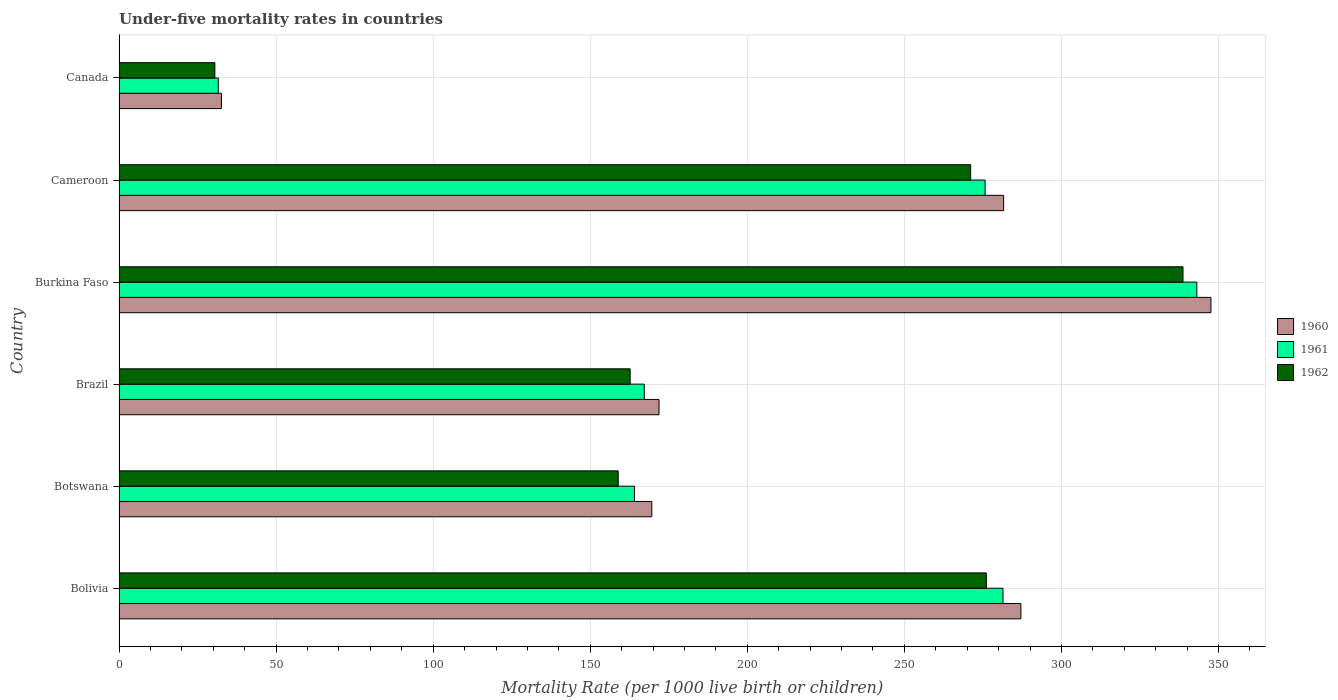Are the number of bars per tick equal to the number of legend labels?
Your response must be concise. Yes. How many bars are there on the 3rd tick from the top?
Keep it short and to the point. 3. How many bars are there on the 5th tick from the bottom?
Offer a terse response. 3. What is the label of the 5th group of bars from the top?
Give a very brief answer. Botswana. What is the under-five mortality rate in 1962 in Cameroon?
Offer a very short reply. 271.1. Across all countries, what is the maximum under-five mortality rate in 1962?
Offer a terse response. 338.7. Across all countries, what is the minimum under-five mortality rate in 1961?
Ensure brevity in your answer.  31.6. In which country was the under-five mortality rate in 1962 maximum?
Your response must be concise. Burkina Faso. In which country was the under-five mortality rate in 1962 minimum?
Ensure brevity in your answer.  Canada. What is the total under-five mortality rate in 1960 in the graph?
Keep it short and to the point. 1290.4. What is the difference between the under-five mortality rate in 1962 in Bolivia and that in Botswana?
Provide a short and direct response. 117.2. What is the difference between the under-five mortality rate in 1962 in Cameroon and the under-five mortality rate in 1961 in Brazil?
Keep it short and to the point. 103.9. What is the average under-five mortality rate in 1961 per country?
Ensure brevity in your answer.  210.52. What is the ratio of the under-five mortality rate in 1960 in Bolivia to that in Canada?
Provide a short and direct response. 8.81. Is the difference between the under-five mortality rate in 1960 in Bolivia and Canada greater than the difference between the under-five mortality rate in 1961 in Bolivia and Canada?
Your answer should be compact. Yes. What is the difference between the highest and the second highest under-five mortality rate in 1960?
Your answer should be compact. 60.5. What is the difference between the highest and the lowest under-five mortality rate in 1961?
Ensure brevity in your answer.  311.5. In how many countries, is the under-five mortality rate in 1961 greater than the average under-five mortality rate in 1961 taken over all countries?
Provide a succinct answer. 3. What does the 1st bar from the top in Cameroon represents?
Offer a very short reply. 1962. Is it the case that in every country, the sum of the under-five mortality rate in 1960 and under-five mortality rate in 1961 is greater than the under-five mortality rate in 1962?
Your response must be concise. Yes. Are all the bars in the graph horizontal?
Your answer should be very brief. Yes. How many countries are there in the graph?
Your answer should be very brief. 6. What is the difference between two consecutive major ticks on the X-axis?
Ensure brevity in your answer.  50. Are the values on the major ticks of X-axis written in scientific E-notation?
Your answer should be compact. No. Does the graph contain any zero values?
Offer a very short reply. No. Where does the legend appear in the graph?
Ensure brevity in your answer.  Center right. How are the legend labels stacked?
Your response must be concise. Vertical. What is the title of the graph?
Ensure brevity in your answer.  Under-five mortality rates in countries. What is the label or title of the X-axis?
Offer a terse response. Mortality Rate (per 1000 live birth or children). What is the Mortality Rate (per 1000 live birth or children) in 1960 in Bolivia?
Give a very brief answer. 287.1. What is the Mortality Rate (per 1000 live birth or children) of 1961 in Bolivia?
Your answer should be compact. 281.4. What is the Mortality Rate (per 1000 live birth or children) of 1962 in Bolivia?
Keep it short and to the point. 276.1. What is the Mortality Rate (per 1000 live birth or children) in 1960 in Botswana?
Your answer should be compact. 169.6. What is the Mortality Rate (per 1000 live birth or children) in 1961 in Botswana?
Give a very brief answer. 164.1. What is the Mortality Rate (per 1000 live birth or children) of 1962 in Botswana?
Keep it short and to the point. 158.9. What is the Mortality Rate (per 1000 live birth or children) in 1960 in Brazil?
Offer a very short reply. 171.9. What is the Mortality Rate (per 1000 live birth or children) of 1961 in Brazil?
Your answer should be very brief. 167.2. What is the Mortality Rate (per 1000 live birth or children) in 1962 in Brazil?
Your response must be concise. 162.7. What is the Mortality Rate (per 1000 live birth or children) in 1960 in Burkina Faso?
Provide a short and direct response. 347.6. What is the Mortality Rate (per 1000 live birth or children) in 1961 in Burkina Faso?
Offer a very short reply. 343.1. What is the Mortality Rate (per 1000 live birth or children) of 1962 in Burkina Faso?
Make the answer very short. 338.7. What is the Mortality Rate (per 1000 live birth or children) of 1960 in Cameroon?
Your answer should be very brief. 281.6. What is the Mortality Rate (per 1000 live birth or children) in 1961 in Cameroon?
Ensure brevity in your answer.  275.7. What is the Mortality Rate (per 1000 live birth or children) of 1962 in Cameroon?
Give a very brief answer. 271.1. What is the Mortality Rate (per 1000 live birth or children) of 1960 in Canada?
Your response must be concise. 32.6. What is the Mortality Rate (per 1000 live birth or children) in 1961 in Canada?
Provide a short and direct response. 31.6. What is the Mortality Rate (per 1000 live birth or children) in 1962 in Canada?
Make the answer very short. 30.5. Across all countries, what is the maximum Mortality Rate (per 1000 live birth or children) of 1960?
Provide a short and direct response. 347.6. Across all countries, what is the maximum Mortality Rate (per 1000 live birth or children) in 1961?
Ensure brevity in your answer.  343.1. Across all countries, what is the maximum Mortality Rate (per 1000 live birth or children) in 1962?
Your answer should be compact. 338.7. Across all countries, what is the minimum Mortality Rate (per 1000 live birth or children) in 1960?
Offer a very short reply. 32.6. Across all countries, what is the minimum Mortality Rate (per 1000 live birth or children) in 1961?
Give a very brief answer. 31.6. Across all countries, what is the minimum Mortality Rate (per 1000 live birth or children) in 1962?
Ensure brevity in your answer.  30.5. What is the total Mortality Rate (per 1000 live birth or children) of 1960 in the graph?
Offer a terse response. 1290.4. What is the total Mortality Rate (per 1000 live birth or children) of 1961 in the graph?
Your answer should be very brief. 1263.1. What is the total Mortality Rate (per 1000 live birth or children) of 1962 in the graph?
Ensure brevity in your answer.  1238. What is the difference between the Mortality Rate (per 1000 live birth or children) in 1960 in Bolivia and that in Botswana?
Give a very brief answer. 117.5. What is the difference between the Mortality Rate (per 1000 live birth or children) of 1961 in Bolivia and that in Botswana?
Your answer should be very brief. 117.3. What is the difference between the Mortality Rate (per 1000 live birth or children) of 1962 in Bolivia and that in Botswana?
Provide a succinct answer. 117.2. What is the difference between the Mortality Rate (per 1000 live birth or children) in 1960 in Bolivia and that in Brazil?
Keep it short and to the point. 115.2. What is the difference between the Mortality Rate (per 1000 live birth or children) of 1961 in Bolivia and that in Brazil?
Provide a succinct answer. 114.2. What is the difference between the Mortality Rate (per 1000 live birth or children) in 1962 in Bolivia and that in Brazil?
Your answer should be very brief. 113.4. What is the difference between the Mortality Rate (per 1000 live birth or children) in 1960 in Bolivia and that in Burkina Faso?
Offer a very short reply. -60.5. What is the difference between the Mortality Rate (per 1000 live birth or children) of 1961 in Bolivia and that in Burkina Faso?
Give a very brief answer. -61.7. What is the difference between the Mortality Rate (per 1000 live birth or children) of 1962 in Bolivia and that in Burkina Faso?
Offer a very short reply. -62.6. What is the difference between the Mortality Rate (per 1000 live birth or children) of 1960 in Bolivia and that in Cameroon?
Provide a short and direct response. 5.5. What is the difference between the Mortality Rate (per 1000 live birth or children) in 1961 in Bolivia and that in Cameroon?
Offer a terse response. 5.7. What is the difference between the Mortality Rate (per 1000 live birth or children) in 1960 in Bolivia and that in Canada?
Your answer should be compact. 254.5. What is the difference between the Mortality Rate (per 1000 live birth or children) in 1961 in Bolivia and that in Canada?
Your answer should be compact. 249.8. What is the difference between the Mortality Rate (per 1000 live birth or children) of 1962 in Bolivia and that in Canada?
Make the answer very short. 245.6. What is the difference between the Mortality Rate (per 1000 live birth or children) of 1961 in Botswana and that in Brazil?
Provide a succinct answer. -3.1. What is the difference between the Mortality Rate (per 1000 live birth or children) of 1962 in Botswana and that in Brazil?
Give a very brief answer. -3.8. What is the difference between the Mortality Rate (per 1000 live birth or children) in 1960 in Botswana and that in Burkina Faso?
Keep it short and to the point. -178. What is the difference between the Mortality Rate (per 1000 live birth or children) in 1961 in Botswana and that in Burkina Faso?
Make the answer very short. -179. What is the difference between the Mortality Rate (per 1000 live birth or children) in 1962 in Botswana and that in Burkina Faso?
Offer a terse response. -179.8. What is the difference between the Mortality Rate (per 1000 live birth or children) of 1960 in Botswana and that in Cameroon?
Your response must be concise. -112. What is the difference between the Mortality Rate (per 1000 live birth or children) in 1961 in Botswana and that in Cameroon?
Make the answer very short. -111.6. What is the difference between the Mortality Rate (per 1000 live birth or children) in 1962 in Botswana and that in Cameroon?
Offer a very short reply. -112.2. What is the difference between the Mortality Rate (per 1000 live birth or children) in 1960 in Botswana and that in Canada?
Your answer should be very brief. 137. What is the difference between the Mortality Rate (per 1000 live birth or children) in 1961 in Botswana and that in Canada?
Ensure brevity in your answer.  132.5. What is the difference between the Mortality Rate (per 1000 live birth or children) in 1962 in Botswana and that in Canada?
Offer a very short reply. 128.4. What is the difference between the Mortality Rate (per 1000 live birth or children) of 1960 in Brazil and that in Burkina Faso?
Your response must be concise. -175.7. What is the difference between the Mortality Rate (per 1000 live birth or children) of 1961 in Brazil and that in Burkina Faso?
Offer a terse response. -175.9. What is the difference between the Mortality Rate (per 1000 live birth or children) in 1962 in Brazil and that in Burkina Faso?
Give a very brief answer. -176. What is the difference between the Mortality Rate (per 1000 live birth or children) of 1960 in Brazil and that in Cameroon?
Your answer should be very brief. -109.7. What is the difference between the Mortality Rate (per 1000 live birth or children) in 1961 in Brazil and that in Cameroon?
Your response must be concise. -108.5. What is the difference between the Mortality Rate (per 1000 live birth or children) in 1962 in Brazil and that in Cameroon?
Provide a succinct answer. -108.4. What is the difference between the Mortality Rate (per 1000 live birth or children) of 1960 in Brazil and that in Canada?
Your answer should be very brief. 139.3. What is the difference between the Mortality Rate (per 1000 live birth or children) of 1961 in Brazil and that in Canada?
Your response must be concise. 135.6. What is the difference between the Mortality Rate (per 1000 live birth or children) in 1962 in Brazil and that in Canada?
Your answer should be compact. 132.2. What is the difference between the Mortality Rate (per 1000 live birth or children) in 1960 in Burkina Faso and that in Cameroon?
Provide a succinct answer. 66. What is the difference between the Mortality Rate (per 1000 live birth or children) of 1961 in Burkina Faso and that in Cameroon?
Offer a very short reply. 67.4. What is the difference between the Mortality Rate (per 1000 live birth or children) of 1962 in Burkina Faso and that in Cameroon?
Your answer should be compact. 67.6. What is the difference between the Mortality Rate (per 1000 live birth or children) in 1960 in Burkina Faso and that in Canada?
Your answer should be compact. 315. What is the difference between the Mortality Rate (per 1000 live birth or children) of 1961 in Burkina Faso and that in Canada?
Give a very brief answer. 311.5. What is the difference between the Mortality Rate (per 1000 live birth or children) of 1962 in Burkina Faso and that in Canada?
Provide a succinct answer. 308.2. What is the difference between the Mortality Rate (per 1000 live birth or children) in 1960 in Cameroon and that in Canada?
Offer a terse response. 249. What is the difference between the Mortality Rate (per 1000 live birth or children) of 1961 in Cameroon and that in Canada?
Make the answer very short. 244.1. What is the difference between the Mortality Rate (per 1000 live birth or children) in 1962 in Cameroon and that in Canada?
Ensure brevity in your answer.  240.6. What is the difference between the Mortality Rate (per 1000 live birth or children) in 1960 in Bolivia and the Mortality Rate (per 1000 live birth or children) in 1961 in Botswana?
Keep it short and to the point. 123. What is the difference between the Mortality Rate (per 1000 live birth or children) in 1960 in Bolivia and the Mortality Rate (per 1000 live birth or children) in 1962 in Botswana?
Your answer should be compact. 128.2. What is the difference between the Mortality Rate (per 1000 live birth or children) in 1961 in Bolivia and the Mortality Rate (per 1000 live birth or children) in 1962 in Botswana?
Provide a succinct answer. 122.5. What is the difference between the Mortality Rate (per 1000 live birth or children) of 1960 in Bolivia and the Mortality Rate (per 1000 live birth or children) of 1961 in Brazil?
Offer a terse response. 119.9. What is the difference between the Mortality Rate (per 1000 live birth or children) in 1960 in Bolivia and the Mortality Rate (per 1000 live birth or children) in 1962 in Brazil?
Ensure brevity in your answer.  124.4. What is the difference between the Mortality Rate (per 1000 live birth or children) in 1961 in Bolivia and the Mortality Rate (per 1000 live birth or children) in 1962 in Brazil?
Offer a terse response. 118.7. What is the difference between the Mortality Rate (per 1000 live birth or children) of 1960 in Bolivia and the Mortality Rate (per 1000 live birth or children) of 1961 in Burkina Faso?
Provide a short and direct response. -56. What is the difference between the Mortality Rate (per 1000 live birth or children) of 1960 in Bolivia and the Mortality Rate (per 1000 live birth or children) of 1962 in Burkina Faso?
Provide a succinct answer. -51.6. What is the difference between the Mortality Rate (per 1000 live birth or children) in 1961 in Bolivia and the Mortality Rate (per 1000 live birth or children) in 1962 in Burkina Faso?
Ensure brevity in your answer.  -57.3. What is the difference between the Mortality Rate (per 1000 live birth or children) in 1960 in Bolivia and the Mortality Rate (per 1000 live birth or children) in 1961 in Cameroon?
Your answer should be very brief. 11.4. What is the difference between the Mortality Rate (per 1000 live birth or children) of 1960 in Bolivia and the Mortality Rate (per 1000 live birth or children) of 1962 in Cameroon?
Give a very brief answer. 16. What is the difference between the Mortality Rate (per 1000 live birth or children) in 1961 in Bolivia and the Mortality Rate (per 1000 live birth or children) in 1962 in Cameroon?
Make the answer very short. 10.3. What is the difference between the Mortality Rate (per 1000 live birth or children) of 1960 in Bolivia and the Mortality Rate (per 1000 live birth or children) of 1961 in Canada?
Offer a very short reply. 255.5. What is the difference between the Mortality Rate (per 1000 live birth or children) of 1960 in Bolivia and the Mortality Rate (per 1000 live birth or children) of 1962 in Canada?
Keep it short and to the point. 256.6. What is the difference between the Mortality Rate (per 1000 live birth or children) in 1961 in Bolivia and the Mortality Rate (per 1000 live birth or children) in 1962 in Canada?
Offer a terse response. 250.9. What is the difference between the Mortality Rate (per 1000 live birth or children) of 1960 in Botswana and the Mortality Rate (per 1000 live birth or children) of 1961 in Brazil?
Offer a very short reply. 2.4. What is the difference between the Mortality Rate (per 1000 live birth or children) in 1961 in Botswana and the Mortality Rate (per 1000 live birth or children) in 1962 in Brazil?
Provide a short and direct response. 1.4. What is the difference between the Mortality Rate (per 1000 live birth or children) of 1960 in Botswana and the Mortality Rate (per 1000 live birth or children) of 1961 in Burkina Faso?
Ensure brevity in your answer.  -173.5. What is the difference between the Mortality Rate (per 1000 live birth or children) in 1960 in Botswana and the Mortality Rate (per 1000 live birth or children) in 1962 in Burkina Faso?
Give a very brief answer. -169.1. What is the difference between the Mortality Rate (per 1000 live birth or children) of 1961 in Botswana and the Mortality Rate (per 1000 live birth or children) of 1962 in Burkina Faso?
Make the answer very short. -174.6. What is the difference between the Mortality Rate (per 1000 live birth or children) of 1960 in Botswana and the Mortality Rate (per 1000 live birth or children) of 1961 in Cameroon?
Provide a short and direct response. -106.1. What is the difference between the Mortality Rate (per 1000 live birth or children) of 1960 in Botswana and the Mortality Rate (per 1000 live birth or children) of 1962 in Cameroon?
Provide a short and direct response. -101.5. What is the difference between the Mortality Rate (per 1000 live birth or children) of 1961 in Botswana and the Mortality Rate (per 1000 live birth or children) of 1962 in Cameroon?
Provide a short and direct response. -107. What is the difference between the Mortality Rate (per 1000 live birth or children) in 1960 in Botswana and the Mortality Rate (per 1000 live birth or children) in 1961 in Canada?
Offer a very short reply. 138. What is the difference between the Mortality Rate (per 1000 live birth or children) of 1960 in Botswana and the Mortality Rate (per 1000 live birth or children) of 1962 in Canada?
Offer a terse response. 139.1. What is the difference between the Mortality Rate (per 1000 live birth or children) of 1961 in Botswana and the Mortality Rate (per 1000 live birth or children) of 1962 in Canada?
Provide a succinct answer. 133.6. What is the difference between the Mortality Rate (per 1000 live birth or children) in 1960 in Brazil and the Mortality Rate (per 1000 live birth or children) in 1961 in Burkina Faso?
Keep it short and to the point. -171.2. What is the difference between the Mortality Rate (per 1000 live birth or children) of 1960 in Brazil and the Mortality Rate (per 1000 live birth or children) of 1962 in Burkina Faso?
Your answer should be compact. -166.8. What is the difference between the Mortality Rate (per 1000 live birth or children) of 1961 in Brazil and the Mortality Rate (per 1000 live birth or children) of 1962 in Burkina Faso?
Make the answer very short. -171.5. What is the difference between the Mortality Rate (per 1000 live birth or children) of 1960 in Brazil and the Mortality Rate (per 1000 live birth or children) of 1961 in Cameroon?
Give a very brief answer. -103.8. What is the difference between the Mortality Rate (per 1000 live birth or children) of 1960 in Brazil and the Mortality Rate (per 1000 live birth or children) of 1962 in Cameroon?
Provide a short and direct response. -99.2. What is the difference between the Mortality Rate (per 1000 live birth or children) in 1961 in Brazil and the Mortality Rate (per 1000 live birth or children) in 1962 in Cameroon?
Your response must be concise. -103.9. What is the difference between the Mortality Rate (per 1000 live birth or children) in 1960 in Brazil and the Mortality Rate (per 1000 live birth or children) in 1961 in Canada?
Your response must be concise. 140.3. What is the difference between the Mortality Rate (per 1000 live birth or children) in 1960 in Brazil and the Mortality Rate (per 1000 live birth or children) in 1962 in Canada?
Ensure brevity in your answer.  141.4. What is the difference between the Mortality Rate (per 1000 live birth or children) in 1961 in Brazil and the Mortality Rate (per 1000 live birth or children) in 1962 in Canada?
Keep it short and to the point. 136.7. What is the difference between the Mortality Rate (per 1000 live birth or children) in 1960 in Burkina Faso and the Mortality Rate (per 1000 live birth or children) in 1961 in Cameroon?
Offer a very short reply. 71.9. What is the difference between the Mortality Rate (per 1000 live birth or children) in 1960 in Burkina Faso and the Mortality Rate (per 1000 live birth or children) in 1962 in Cameroon?
Keep it short and to the point. 76.5. What is the difference between the Mortality Rate (per 1000 live birth or children) of 1961 in Burkina Faso and the Mortality Rate (per 1000 live birth or children) of 1962 in Cameroon?
Ensure brevity in your answer.  72. What is the difference between the Mortality Rate (per 1000 live birth or children) in 1960 in Burkina Faso and the Mortality Rate (per 1000 live birth or children) in 1961 in Canada?
Your answer should be compact. 316. What is the difference between the Mortality Rate (per 1000 live birth or children) of 1960 in Burkina Faso and the Mortality Rate (per 1000 live birth or children) of 1962 in Canada?
Your answer should be compact. 317.1. What is the difference between the Mortality Rate (per 1000 live birth or children) of 1961 in Burkina Faso and the Mortality Rate (per 1000 live birth or children) of 1962 in Canada?
Keep it short and to the point. 312.6. What is the difference between the Mortality Rate (per 1000 live birth or children) of 1960 in Cameroon and the Mortality Rate (per 1000 live birth or children) of 1961 in Canada?
Offer a terse response. 250. What is the difference between the Mortality Rate (per 1000 live birth or children) of 1960 in Cameroon and the Mortality Rate (per 1000 live birth or children) of 1962 in Canada?
Provide a short and direct response. 251.1. What is the difference between the Mortality Rate (per 1000 live birth or children) in 1961 in Cameroon and the Mortality Rate (per 1000 live birth or children) in 1962 in Canada?
Your answer should be very brief. 245.2. What is the average Mortality Rate (per 1000 live birth or children) in 1960 per country?
Offer a very short reply. 215.07. What is the average Mortality Rate (per 1000 live birth or children) in 1961 per country?
Provide a short and direct response. 210.52. What is the average Mortality Rate (per 1000 live birth or children) in 1962 per country?
Provide a short and direct response. 206.33. What is the difference between the Mortality Rate (per 1000 live birth or children) of 1960 and Mortality Rate (per 1000 live birth or children) of 1961 in Bolivia?
Provide a succinct answer. 5.7. What is the difference between the Mortality Rate (per 1000 live birth or children) of 1961 and Mortality Rate (per 1000 live birth or children) of 1962 in Bolivia?
Provide a succinct answer. 5.3. What is the difference between the Mortality Rate (per 1000 live birth or children) in 1960 and Mortality Rate (per 1000 live birth or children) in 1961 in Botswana?
Your response must be concise. 5.5. What is the difference between the Mortality Rate (per 1000 live birth or children) of 1960 and Mortality Rate (per 1000 live birth or children) of 1962 in Botswana?
Keep it short and to the point. 10.7. What is the difference between the Mortality Rate (per 1000 live birth or children) in 1960 and Mortality Rate (per 1000 live birth or children) in 1961 in Brazil?
Your answer should be very brief. 4.7. What is the difference between the Mortality Rate (per 1000 live birth or children) in 1960 and Mortality Rate (per 1000 live birth or children) in 1962 in Brazil?
Offer a very short reply. 9.2. What is the difference between the Mortality Rate (per 1000 live birth or children) in 1961 and Mortality Rate (per 1000 live birth or children) in 1962 in Brazil?
Your response must be concise. 4.5. What is the difference between the Mortality Rate (per 1000 live birth or children) in 1960 and Mortality Rate (per 1000 live birth or children) in 1961 in Burkina Faso?
Give a very brief answer. 4.5. What is the difference between the Mortality Rate (per 1000 live birth or children) of 1961 and Mortality Rate (per 1000 live birth or children) of 1962 in Burkina Faso?
Ensure brevity in your answer.  4.4. What is the difference between the Mortality Rate (per 1000 live birth or children) in 1960 and Mortality Rate (per 1000 live birth or children) in 1962 in Cameroon?
Offer a terse response. 10.5. What is the difference between the Mortality Rate (per 1000 live birth or children) in 1961 and Mortality Rate (per 1000 live birth or children) in 1962 in Cameroon?
Provide a short and direct response. 4.6. What is the difference between the Mortality Rate (per 1000 live birth or children) of 1960 and Mortality Rate (per 1000 live birth or children) of 1961 in Canada?
Make the answer very short. 1. What is the difference between the Mortality Rate (per 1000 live birth or children) in 1961 and Mortality Rate (per 1000 live birth or children) in 1962 in Canada?
Keep it short and to the point. 1.1. What is the ratio of the Mortality Rate (per 1000 live birth or children) of 1960 in Bolivia to that in Botswana?
Provide a short and direct response. 1.69. What is the ratio of the Mortality Rate (per 1000 live birth or children) in 1961 in Bolivia to that in Botswana?
Make the answer very short. 1.71. What is the ratio of the Mortality Rate (per 1000 live birth or children) of 1962 in Bolivia to that in Botswana?
Provide a succinct answer. 1.74. What is the ratio of the Mortality Rate (per 1000 live birth or children) in 1960 in Bolivia to that in Brazil?
Your answer should be compact. 1.67. What is the ratio of the Mortality Rate (per 1000 live birth or children) of 1961 in Bolivia to that in Brazil?
Give a very brief answer. 1.68. What is the ratio of the Mortality Rate (per 1000 live birth or children) in 1962 in Bolivia to that in Brazil?
Offer a terse response. 1.7. What is the ratio of the Mortality Rate (per 1000 live birth or children) of 1960 in Bolivia to that in Burkina Faso?
Your answer should be very brief. 0.83. What is the ratio of the Mortality Rate (per 1000 live birth or children) in 1961 in Bolivia to that in Burkina Faso?
Make the answer very short. 0.82. What is the ratio of the Mortality Rate (per 1000 live birth or children) of 1962 in Bolivia to that in Burkina Faso?
Provide a short and direct response. 0.82. What is the ratio of the Mortality Rate (per 1000 live birth or children) of 1960 in Bolivia to that in Cameroon?
Offer a very short reply. 1.02. What is the ratio of the Mortality Rate (per 1000 live birth or children) in 1961 in Bolivia to that in Cameroon?
Ensure brevity in your answer.  1.02. What is the ratio of the Mortality Rate (per 1000 live birth or children) in 1962 in Bolivia to that in Cameroon?
Provide a succinct answer. 1.02. What is the ratio of the Mortality Rate (per 1000 live birth or children) of 1960 in Bolivia to that in Canada?
Your answer should be very brief. 8.81. What is the ratio of the Mortality Rate (per 1000 live birth or children) in 1961 in Bolivia to that in Canada?
Ensure brevity in your answer.  8.91. What is the ratio of the Mortality Rate (per 1000 live birth or children) of 1962 in Bolivia to that in Canada?
Ensure brevity in your answer.  9.05. What is the ratio of the Mortality Rate (per 1000 live birth or children) of 1960 in Botswana to that in Brazil?
Give a very brief answer. 0.99. What is the ratio of the Mortality Rate (per 1000 live birth or children) in 1961 in Botswana to that in Brazil?
Offer a terse response. 0.98. What is the ratio of the Mortality Rate (per 1000 live birth or children) in 1962 in Botswana to that in Brazil?
Your answer should be compact. 0.98. What is the ratio of the Mortality Rate (per 1000 live birth or children) in 1960 in Botswana to that in Burkina Faso?
Your answer should be very brief. 0.49. What is the ratio of the Mortality Rate (per 1000 live birth or children) of 1961 in Botswana to that in Burkina Faso?
Provide a succinct answer. 0.48. What is the ratio of the Mortality Rate (per 1000 live birth or children) in 1962 in Botswana to that in Burkina Faso?
Your response must be concise. 0.47. What is the ratio of the Mortality Rate (per 1000 live birth or children) in 1960 in Botswana to that in Cameroon?
Your response must be concise. 0.6. What is the ratio of the Mortality Rate (per 1000 live birth or children) in 1961 in Botswana to that in Cameroon?
Provide a short and direct response. 0.6. What is the ratio of the Mortality Rate (per 1000 live birth or children) in 1962 in Botswana to that in Cameroon?
Make the answer very short. 0.59. What is the ratio of the Mortality Rate (per 1000 live birth or children) of 1960 in Botswana to that in Canada?
Keep it short and to the point. 5.2. What is the ratio of the Mortality Rate (per 1000 live birth or children) of 1961 in Botswana to that in Canada?
Provide a short and direct response. 5.19. What is the ratio of the Mortality Rate (per 1000 live birth or children) in 1962 in Botswana to that in Canada?
Keep it short and to the point. 5.21. What is the ratio of the Mortality Rate (per 1000 live birth or children) in 1960 in Brazil to that in Burkina Faso?
Your response must be concise. 0.49. What is the ratio of the Mortality Rate (per 1000 live birth or children) of 1961 in Brazil to that in Burkina Faso?
Provide a short and direct response. 0.49. What is the ratio of the Mortality Rate (per 1000 live birth or children) in 1962 in Brazil to that in Burkina Faso?
Offer a very short reply. 0.48. What is the ratio of the Mortality Rate (per 1000 live birth or children) in 1960 in Brazil to that in Cameroon?
Make the answer very short. 0.61. What is the ratio of the Mortality Rate (per 1000 live birth or children) of 1961 in Brazil to that in Cameroon?
Provide a succinct answer. 0.61. What is the ratio of the Mortality Rate (per 1000 live birth or children) in 1962 in Brazil to that in Cameroon?
Your answer should be very brief. 0.6. What is the ratio of the Mortality Rate (per 1000 live birth or children) of 1960 in Brazil to that in Canada?
Keep it short and to the point. 5.27. What is the ratio of the Mortality Rate (per 1000 live birth or children) in 1961 in Brazil to that in Canada?
Keep it short and to the point. 5.29. What is the ratio of the Mortality Rate (per 1000 live birth or children) of 1962 in Brazil to that in Canada?
Your answer should be compact. 5.33. What is the ratio of the Mortality Rate (per 1000 live birth or children) in 1960 in Burkina Faso to that in Cameroon?
Offer a very short reply. 1.23. What is the ratio of the Mortality Rate (per 1000 live birth or children) in 1961 in Burkina Faso to that in Cameroon?
Your response must be concise. 1.24. What is the ratio of the Mortality Rate (per 1000 live birth or children) of 1962 in Burkina Faso to that in Cameroon?
Your answer should be compact. 1.25. What is the ratio of the Mortality Rate (per 1000 live birth or children) in 1960 in Burkina Faso to that in Canada?
Your answer should be compact. 10.66. What is the ratio of the Mortality Rate (per 1000 live birth or children) in 1961 in Burkina Faso to that in Canada?
Provide a succinct answer. 10.86. What is the ratio of the Mortality Rate (per 1000 live birth or children) in 1962 in Burkina Faso to that in Canada?
Provide a succinct answer. 11.1. What is the ratio of the Mortality Rate (per 1000 live birth or children) of 1960 in Cameroon to that in Canada?
Your answer should be compact. 8.64. What is the ratio of the Mortality Rate (per 1000 live birth or children) of 1961 in Cameroon to that in Canada?
Your answer should be very brief. 8.72. What is the ratio of the Mortality Rate (per 1000 live birth or children) in 1962 in Cameroon to that in Canada?
Give a very brief answer. 8.89. What is the difference between the highest and the second highest Mortality Rate (per 1000 live birth or children) in 1960?
Give a very brief answer. 60.5. What is the difference between the highest and the second highest Mortality Rate (per 1000 live birth or children) in 1961?
Give a very brief answer. 61.7. What is the difference between the highest and the second highest Mortality Rate (per 1000 live birth or children) of 1962?
Keep it short and to the point. 62.6. What is the difference between the highest and the lowest Mortality Rate (per 1000 live birth or children) of 1960?
Your answer should be very brief. 315. What is the difference between the highest and the lowest Mortality Rate (per 1000 live birth or children) in 1961?
Your answer should be compact. 311.5. What is the difference between the highest and the lowest Mortality Rate (per 1000 live birth or children) in 1962?
Your answer should be very brief. 308.2. 